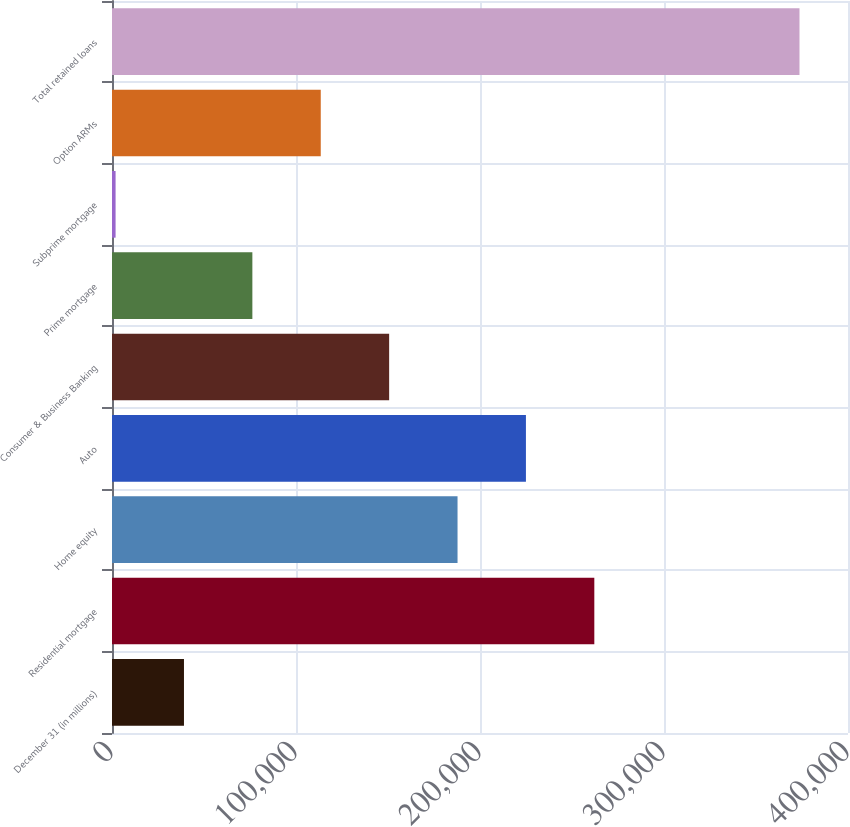Convert chart to OTSL. <chart><loc_0><loc_0><loc_500><loc_500><bar_chart><fcel>December 31 (in millions)<fcel>Residential mortgage<fcel>Home equity<fcel>Auto<fcel>Consumer & Business Banking<fcel>Prime mortgage<fcel>Subprime mortgage<fcel>Option ARMs<fcel>Total retained loans<nl><fcel>39114.2<fcel>262129<fcel>187791<fcel>224960<fcel>150622<fcel>76283.4<fcel>1945<fcel>113453<fcel>373637<nl></chart> 